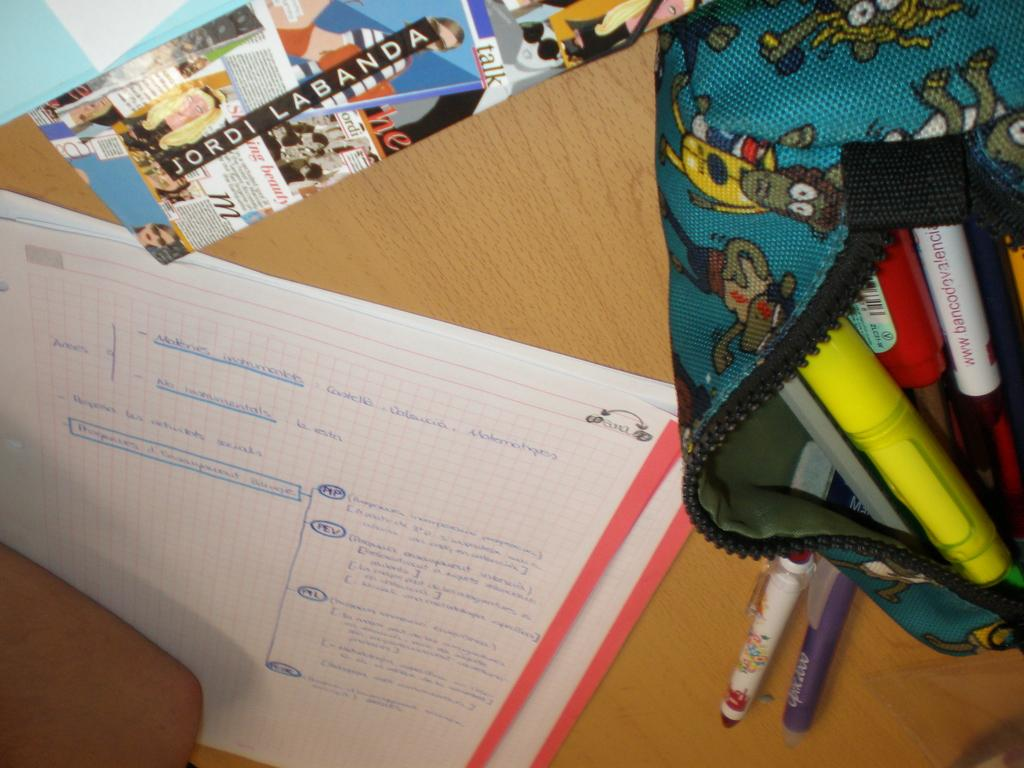<image>
Write a terse but informative summary of the picture. a graph paper with writing documented on it with JORDI LABANDA paperwork above it 